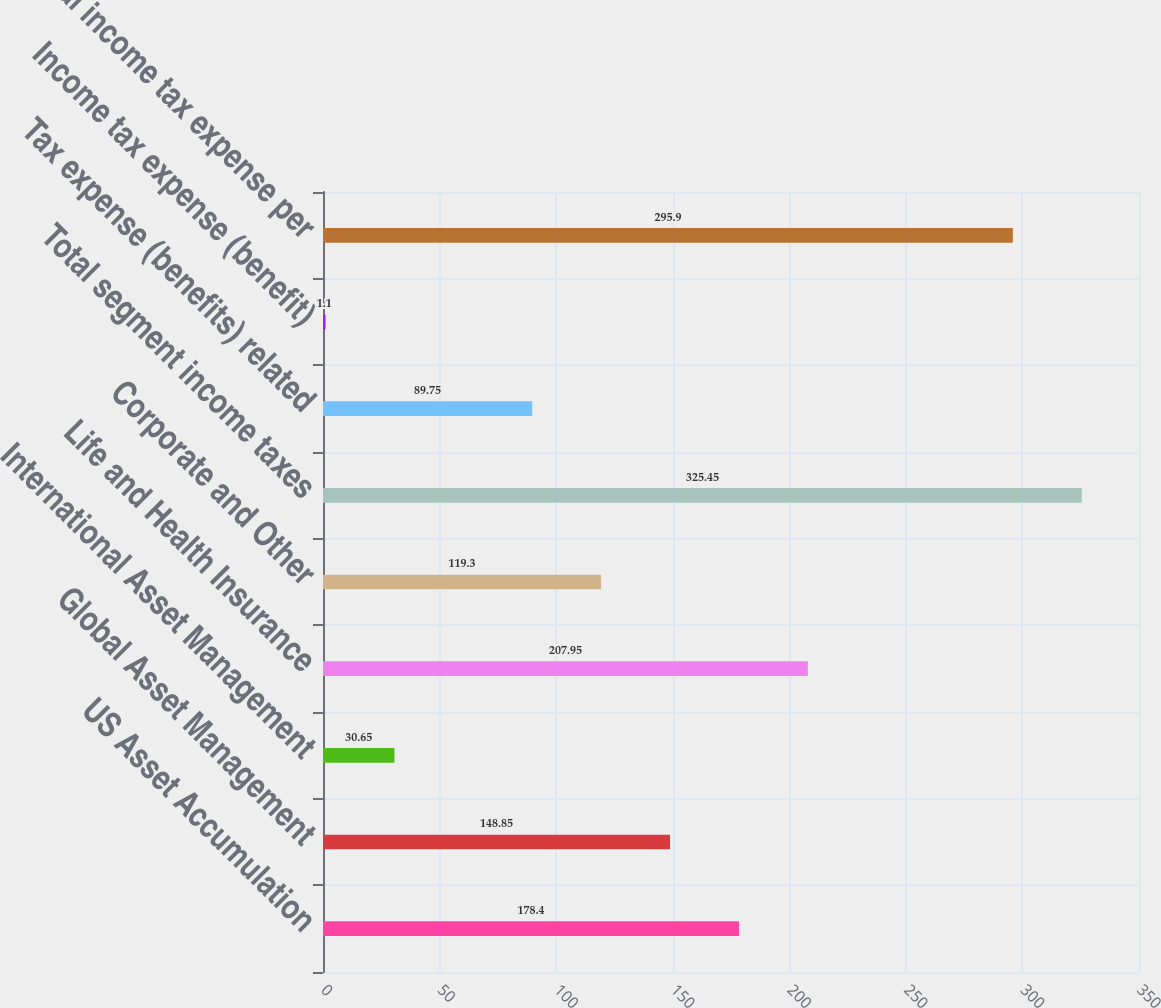Convert chart to OTSL. <chart><loc_0><loc_0><loc_500><loc_500><bar_chart><fcel>US Asset Accumulation<fcel>Global Asset Management<fcel>International Asset Management<fcel>Life and Health Insurance<fcel>Corporate and Other<fcel>Total segment income taxes<fcel>Tax expense (benefits) related<fcel>Income tax expense (benefit)<fcel>Total income tax expense per<nl><fcel>178.4<fcel>148.85<fcel>30.65<fcel>207.95<fcel>119.3<fcel>325.45<fcel>89.75<fcel>1.1<fcel>295.9<nl></chart> 